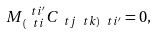Convert formula to latex. <formula><loc_0><loc_0><loc_500><loc_500>M ^ { \ t i ^ { \prime } } _ { \, ( \ t i } C _ { \ t j \ t k ) \ t i ^ { \prime } } = 0 ,</formula> 